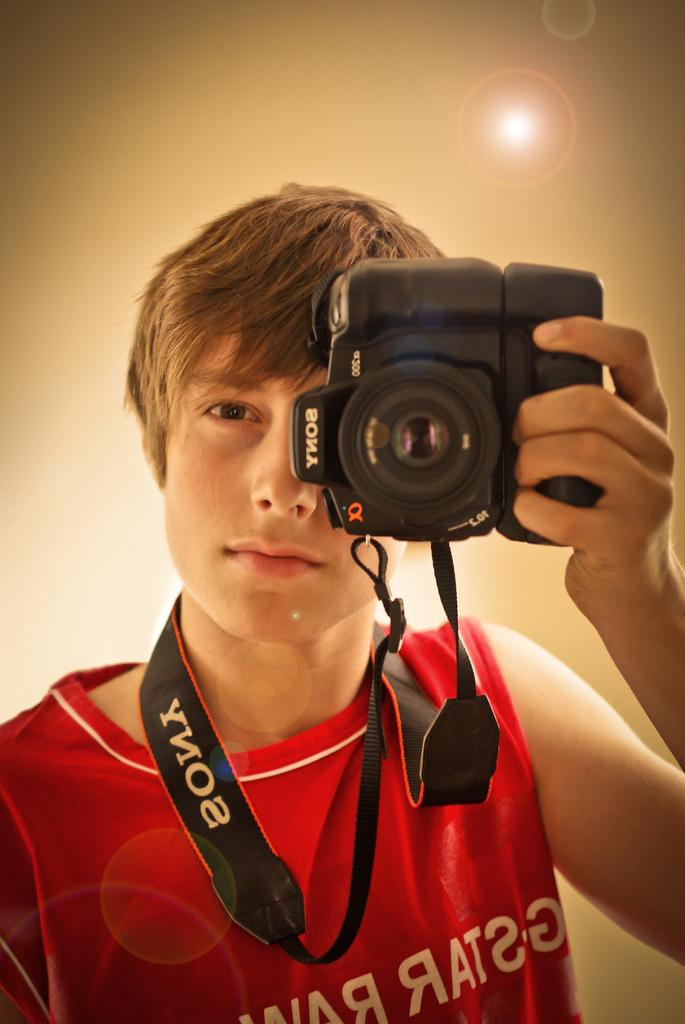Who is present in the image? There is a man in the image. What is the man wearing? The man is wearing a red T-shirt. What is the man holding around his neck? The man is holding a camera around his neck. What is the man doing in the image? The man is taking a snapshot. What can be seen in the background of the image? There is sunlight visible behind the man. How many caves can be seen in the image? There are no caves present in the image. What is the man's wealth status in the image? The image does not provide any information about the man's wealth status. 